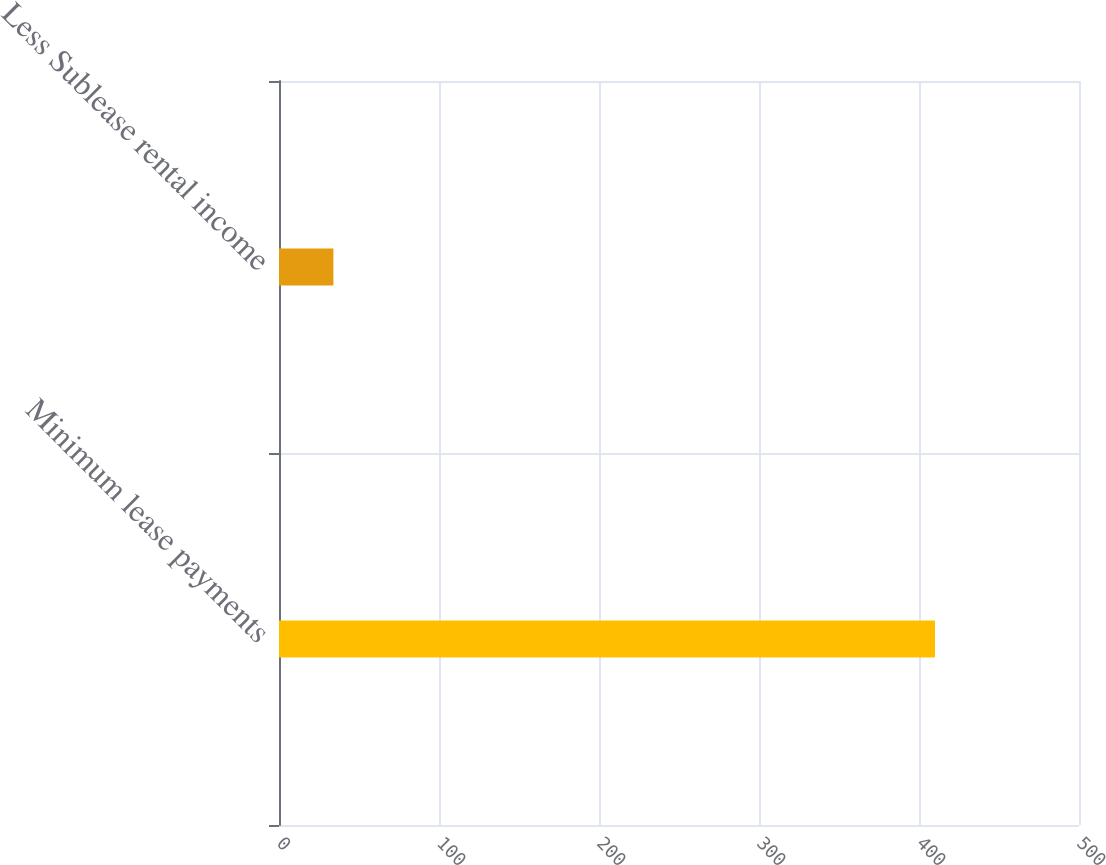Convert chart. <chart><loc_0><loc_0><loc_500><loc_500><bar_chart><fcel>Minimum lease payments<fcel>Less Sublease rental income<nl><fcel>410<fcel>34<nl></chart> 